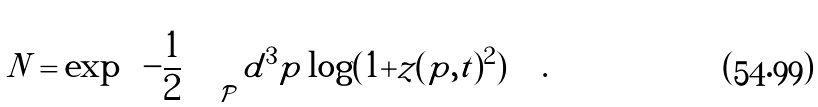<formula> <loc_0><loc_0><loc_500><loc_500>N = \exp \left ( - \frac { 1 } { 2 } \int _ { \mathcal { P } } d ^ { 3 } p \log ( 1 + | z ( p , t ) | ^ { 2 } ) \right ) .</formula> 